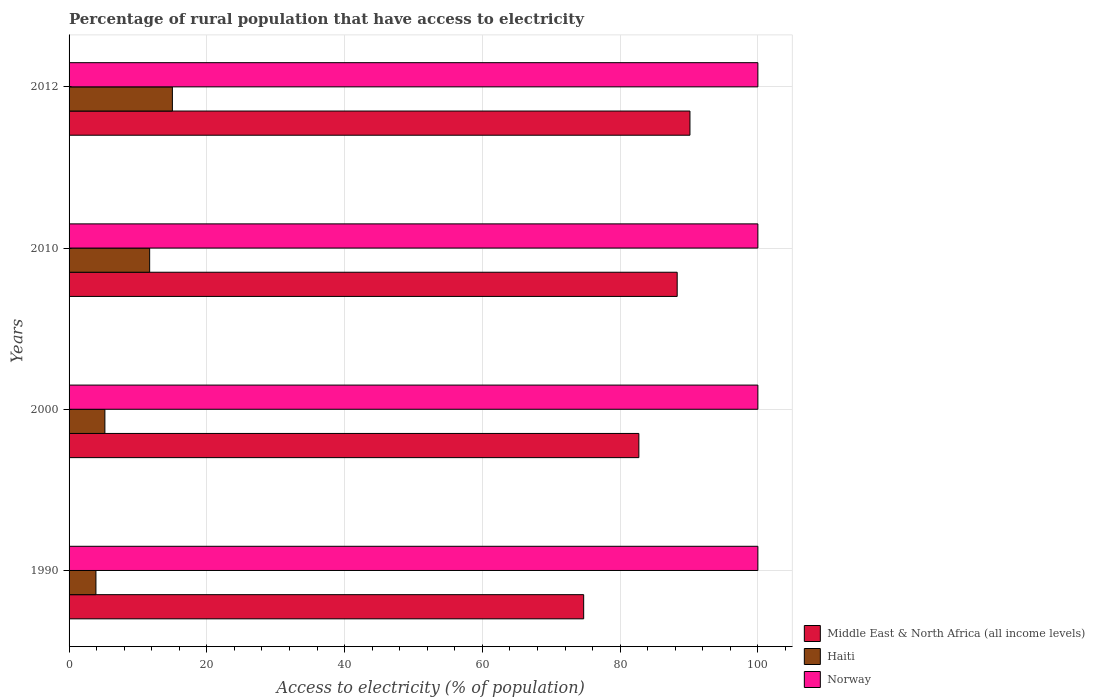How many different coloured bars are there?
Ensure brevity in your answer.  3. How many groups of bars are there?
Your answer should be very brief. 4. How many bars are there on the 3rd tick from the top?
Provide a succinct answer. 3. How many bars are there on the 1st tick from the bottom?
Provide a succinct answer. 3. What is the label of the 3rd group of bars from the top?
Give a very brief answer. 2000. In how many cases, is the number of bars for a given year not equal to the number of legend labels?
Provide a succinct answer. 0. What is the percentage of rural population that have access to electricity in Norway in 2010?
Make the answer very short. 100. Across all years, what is the maximum percentage of rural population that have access to electricity in Middle East & North Africa (all income levels)?
Your response must be concise. 90.14. Across all years, what is the minimum percentage of rural population that have access to electricity in Haiti?
Ensure brevity in your answer.  3.9. What is the total percentage of rural population that have access to electricity in Middle East & North Africa (all income levels) in the graph?
Your answer should be very brief. 335.85. What is the difference between the percentage of rural population that have access to electricity in Middle East & North Africa (all income levels) in 1990 and that in 2010?
Keep it short and to the point. -13.57. What is the difference between the percentage of rural population that have access to electricity in Norway in 2010 and the percentage of rural population that have access to electricity in Haiti in 2000?
Your answer should be very brief. 94.8. What is the average percentage of rural population that have access to electricity in Norway per year?
Give a very brief answer. 100. In the year 2010, what is the difference between the percentage of rural population that have access to electricity in Norway and percentage of rural population that have access to electricity in Haiti?
Make the answer very short. 88.3. What is the ratio of the percentage of rural population that have access to electricity in Haiti in 2000 to that in 2012?
Your answer should be very brief. 0.35. Is the percentage of rural population that have access to electricity in Norway in 1990 less than that in 2000?
Your answer should be very brief. No. What is the difference between the highest and the second highest percentage of rural population that have access to electricity in Haiti?
Ensure brevity in your answer.  3.3. What is the difference between the highest and the lowest percentage of rural population that have access to electricity in Norway?
Provide a succinct answer. 0. In how many years, is the percentage of rural population that have access to electricity in Norway greater than the average percentage of rural population that have access to electricity in Norway taken over all years?
Your answer should be compact. 0. Is the sum of the percentage of rural population that have access to electricity in Norway in 1990 and 2000 greater than the maximum percentage of rural population that have access to electricity in Middle East & North Africa (all income levels) across all years?
Your answer should be very brief. Yes. What does the 3rd bar from the top in 2012 represents?
Provide a succinct answer. Middle East & North Africa (all income levels). What does the 1st bar from the bottom in 2012 represents?
Your response must be concise. Middle East & North Africa (all income levels). How many bars are there?
Provide a short and direct response. 12. Are all the bars in the graph horizontal?
Your answer should be compact. Yes. What is the difference between two consecutive major ticks on the X-axis?
Offer a very short reply. 20. Are the values on the major ticks of X-axis written in scientific E-notation?
Ensure brevity in your answer.  No. Does the graph contain grids?
Make the answer very short. Yes. How many legend labels are there?
Give a very brief answer. 3. What is the title of the graph?
Keep it short and to the point. Percentage of rural population that have access to electricity. Does "Australia" appear as one of the legend labels in the graph?
Provide a succinct answer. No. What is the label or title of the X-axis?
Provide a succinct answer. Access to electricity (% of population). What is the label or title of the Y-axis?
Your answer should be very brief. Years. What is the Access to electricity (% of population) of Middle East & North Africa (all income levels) in 1990?
Keep it short and to the point. 74.71. What is the Access to electricity (% of population) in Haiti in 1990?
Give a very brief answer. 3.9. What is the Access to electricity (% of population) in Norway in 1990?
Provide a succinct answer. 100. What is the Access to electricity (% of population) in Middle East & North Africa (all income levels) in 2000?
Offer a terse response. 82.72. What is the Access to electricity (% of population) in Haiti in 2000?
Offer a terse response. 5.2. What is the Access to electricity (% of population) in Middle East & North Africa (all income levels) in 2010?
Make the answer very short. 88.28. What is the Access to electricity (% of population) of Haiti in 2010?
Provide a short and direct response. 11.7. What is the Access to electricity (% of population) of Middle East & North Africa (all income levels) in 2012?
Offer a terse response. 90.14. What is the Access to electricity (% of population) in Norway in 2012?
Your response must be concise. 100. Across all years, what is the maximum Access to electricity (% of population) of Middle East & North Africa (all income levels)?
Your answer should be very brief. 90.14. Across all years, what is the maximum Access to electricity (% of population) of Haiti?
Make the answer very short. 15. Across all years, what is the minimum Access to electricity (% of population) in Middle East & North Africa (all income levels)?
Make the answer very short. 74.71. Across all years, what is the minimum Access to electricity (% of population) of Norway?
Provide a short and direct response. 100. What is the total Access to electricity (% of population) of Middle East & North Africa (all income levels) in the graph?
Your answer should be compact. 335.85. What is the total Access to electricity (% of population) in Haiti in the graph?
Keep it short and to the point. 35.8. What is the total Access to electricity (% of population) in Norway in the graph?
Your response must be concise. 400. What is the difference between the Access to electricity (% of population) of Middle East & North Africa (all income levels) in 1990 and that in 2000?
Provide a short and direct response. -8.01. What is the difference between the Access to electricity (% of population) in Haiti in 1990 and that in 2000?
Provide a short and direct response. -1.3. What is the difference between the Access to electricity (% of population) of Norway in 1990 and that in 2000?
Offer a very short reply. 0. What is the difference between the Access to electricity (% of population) in Middle East & North Africa (all income levels) in 1990 and that in 2010?
Give a very brief answer. -13.57. What is the difference between the Access to electricity (% of population) in Middle East & North Africa (all income levels) in 1990 and that in 2012?
Your answer should be compact. -15.43. What is the difference between the Access to electricity (% of population) in Middle East & North Africa (all income levels) in 2000 and that in 2010?
Provide a short and direct response. -5.56. What is the difference between the Access to electricity (% of population) of Norway in 2000 and that in 2010?
Provide a short and direct response. 0. What is the difference between the Access to electricity (% of population) of Middle East & North Africa (all income levels) in 2000 and that in 2012?
Your answer should be very brief. -7.42. What is the difference between the Access to electricity (% of population) of Norway in 2000 and that in 2012?
Offer a very short reply. 0. What is the difference between the Access to electricity (% of population) in Middle East & North Africa (all income levels) in 2010 and that in 2012?
Your answer should be compact. -1.85. What is the difference between the Access to electricity (% of population) of Middle East & North Africa (all income levels) in 1990 and the Access to electricity (% of population) of Haiti in 2000?
Make the answer very short. 69.51. What is the difference between the Access to electricity (% of population) of Middle East & North Africa (all income levels) in 1990 and the Access to electricity (% of population) of Norway in 2000?
Provide a succinct answer. -25.29. What is the difference between the Access to electricity (% of population) in Haiti in 1990 and the Access to electricity (% of population) in Norway in 2000?
Provide a short and direct response. -96.1. What is the difference between the Access to electricity (% of population) of Middle East & North Africa (all income levels) in 1990 and the Access to electricity (% of population) of Haiti in 2010?
Give a very brief answer. 63.01. What is the difference between the Access to electricity (% of population) of Middle East & North Africa (all income levels) in 1990 and the Access to electricity (% of population) of Norway in 2010?
Offer a very short reply. -25.29. What is the difference between the Access to electricity (% of population) in Haiti in 1990 and the Access to electricity (% of population) in Norway in 2010?
Offer a terse response. -96.1. What is the difference between the Access to electricity (% of population) of Middle East & North Africa (all income levels) in 1990 and the Access to electricity (% of population) of Haiti in 2012?
Ensure brevity in your answer.  59.71. What is the difference between the Access to electricity (% of population) of Middle East & North Africa (all income levels) in 1990 and the Access to electricity (% of population) of Norway in 2012?
Provide a succinct answer. -25.29. What is the difference between the Access to electricity (% of population) of Haiti in 1990 and the Access to electricity (% of population) of Norway in 2012?
Keep it short and to the point. -96.1. What is the difference between the Access to electricity (% of population) of Middle East & North Africa (all income levels) in 2000 and the Access to electricity (% of population) of Haiti in 2010?
Give a very brief answer. 71.02. What is the difference between the Access to electricity (% of population) in Middle East & North Africa (all income levels) in 2000 and the Access to electricity (% of population) in Norway in 2010?
Offer a very short reply. -17.28. What is the difference between the Access to electricity (% of population) in Haiti in 2000 and the Access to electricity (% of population) in Norway in 2010?
Provide a succinct answer. -94.8. What is the difference between the Access to electricity (% of population) in Middle East & North Africa (all income levels) in 2000 and the Access to electricity (% of population) in Haiti in 2012?
Provide a succinct answer. 67.72. What is the difference between the Access to electricity (% of population) in Middle East & North Africa (all income levels) in 2000 and the Access to electricity (% of population) in Norway in 2012?
Offer a very short reply. -17.28. What is the difference between the Access to electricity (% of population) of Haiti in 2000 and the Access to electricity (% of population) of Norway in 2012?
Provide a short and direct response. -94.8. What is the difference between the Access to electricity (% of population) of Middle East & North Africa (all income levels) in 2010 and the Access to electricity (% of population) of Haiti in 2012?
Provide a succinct answer. 73.28. What is the difference between the Access to electricity (% of population) in Middle East & North Africa (all income levels) in 2010 and the Access to electricity (% of population) in Norway in 2012?
Offer a terse response. -11.72. What is the difference between the Access to electricity (% of population) in Haiti in 2010 and the Access to electricity (% of population) in Norway in 2012?
Your answer should be compact. -88.3. What is the average Access to electricity (% of population) of Middle East & North Africa (all income levels) per year?
Offer a very short reply. 83.96. What is the average Access to electricity (% of population) in Haiti per year?
Ensure brevity in your answer.  8.95. What is the average Access to electricity (% of population) in Norway per year?
Give a very brief answer. 100. In the year 1990, what is the difference between the Access to electricity (% of population) in Middle East & North Africa (all income levels) and Access to electricity (% of population) in Haiti?
Your answer should be compact. 70.81. In the year 1990, what is the difference between the Access to electricity (% of population) of Middle East & North Africa (all income levels) and Access to electricity (% of population) of Norway?
Your answer should be very brief. -25.29. In the year 1990, what is the difference between the Access to electricity (% of population) in Haiti and Access to electricity (% of population) in Norway?
Your response must be concise. -96.1. In the year 2000, what is the difference between the Access to electricity (% of population) of Middle East & North Africa (all income levels) and Access to electricity (% of population) of Haiti?
Offer a terse response. 77.52. In the year 2000, what is the difference between the Access to electricity (% of population) of Middle East & North Africa (all income levels) and Access to electricity (% of population) of Norway?
Your answer should be compact. -17.28. In the year 2000, what is the difference between the Access to electricity (% of population) in Haiti and Access to electricity (% of population) in Norway?
Make the answer very short. -94.8. In the year 2010, what is the difference between the Access to electricity (% of population) of Middle East & North Africa (all income levels) and Access to electricity (% of population) of Haiti?
Ensure brevity in your answer.  76.58. In the year 2010, what is the difference between the Access to electricity (% of population) in Middle East & North Africa (all income levels) and Access to electricity (% of population) in Norway?
Give a very brief answer. -11.72. In the year 2010, what is the difference between the Access to electricity (% of population) in Haiti and Access to electricity (% of population) in Norway?
Your answer should be compact. -88.3. In the year 2012, what is the difference between the Access to electricity (% of population) of Middle East & North Africa (all income levels) and Access to electricity (% of population) of Haiti?
Keep it short and to the point. 75.14. In the year 2012, what is the difference between the Access to electricity (% of population) in Middle East & North Africa (all income levels) and Access to electricity (% of population) in Norway?
Provide a short and direct response. -9.86. In the year 2012, what is the difference between the Access to electricity (% of population) of Haiti and Access to electricity (% of population) of Norway?
Make the answer very short. -85. What is the ratio of the Access to electricity (% of population) in Middle East & North Africa (all income levels) in 1990 to that in 2000?
Provide a short and direct response. 0.9. What is the ratio of the Access to electricity (% of population) in Norway in 1990 to that in 2000?
Make the answer very short. 1. What is the ratio of the Access to electricity (% of population) in Middle East & North Africa (all income levels) in 1990 to that in 2010?
Provide a short and direct response. 0.85. What is the ratio of the Access to electricity (% of population) of Haiti in 1990 to that in 2010?
Offer a very short reply. 0.33. What is the ratio of the Access to electricity (% of population) in Middle East & North Africa (all income levels) in 1990 to that in 2012?
Keep it short and to the point. 0.83. What is the ratio of the Access to electricity (% of population) of Haiti in 1990 to that in 2012?
Ensure brevity in your answer.  0.26. What is the ratio of the Access to electricity (% of population) in Norway in 1990 to that in 2012?
Ensure brevity in your answer.  1. What is the ratio of the Access to electricity (% of population) of Middle East & North Africa (all income levels) in 2000 to that in 2010?
Ensure brevity in your answer.  0.94. What is the ratio of the Access to electricity (% of population) in Haiti in 2000 to that in 2010?
Ensure brevity in your answer.  0.44. What is the ratio of the Access to electricity (% of population) in Middle East & North Africa (all income levels) in 2000 to that in 2012?
Ensure brevity in your answer.  0.92. What is the ratio of the Access to electricity (% of population) in Haiti in 2000 to that in 2012?
Offer a very short reply. 0.35. What is the ratio of the Access to electricity (% of population) in Norway in 2000 to that in 2012?
Offer a terse response. 1. What is the ratio of the Access to electricity (% of population) of Middle East & North Africa (all income levels) in 2010 to that in 2012?
Offer a very short reply. 0.98. What is the ratio of the Access to electricity (% of population) in Haiti in 2010 to that in 2012?
Ensure brevity in your answer.  0.78. What is the difference between the highest and the second highest Access to electricity (% of population) of Middle East & North Africa (all income levels)?
Make the answer very short. 1.85. What is the difference between the highest and the lowest Access to electricity (% of population) in Middle East & North Africa (all income levels)?
Offer a very short reply. 15.43. What is the difference between the highest and the lowest Access to electricity (% of population) of Norway?
Give a very brief answer. 0. 